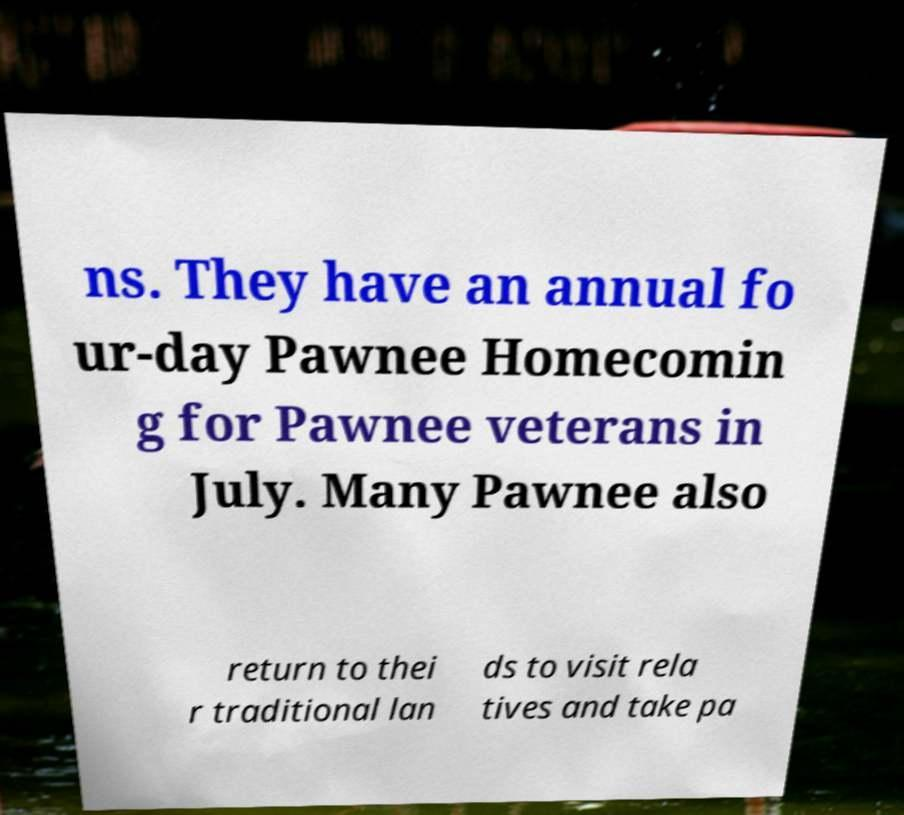For documentation purposes, I need the text within this image transcribed. Could you provide that? ns. They have an annual fo ur-day Pawnee Homecomin g for Pawnee veterans in July. Many Pawnee also return to thei r traditional lan ds to visit rela tives and take pa 